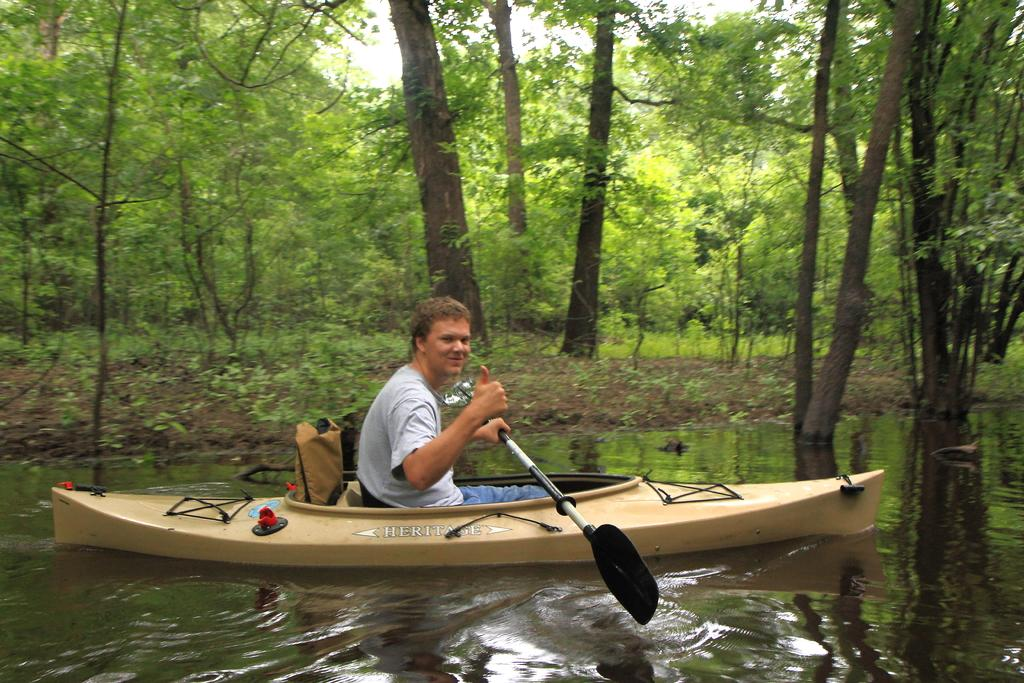What is the person in the image doing? The person is sitting on a boat. What is the person holding in the image? The person is holding a paddle. Where is the boat located in the image? The boat is in the water. What can be seen in the background of the image? There are trees in the background of the image. What type of silver instrument is the person playing in the image? There is no silver instrument present in the image, and the person is not playing any instrument. 